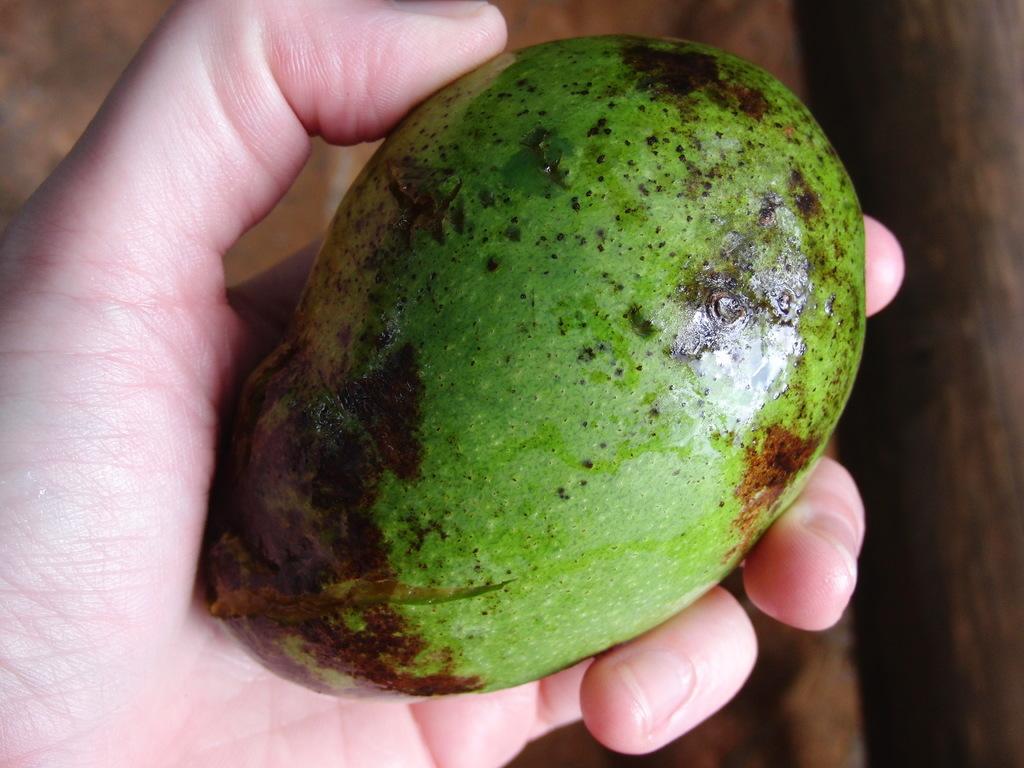How would you summarize this image in a sentence or two? In this image I see a person's hand holding a fruit. 